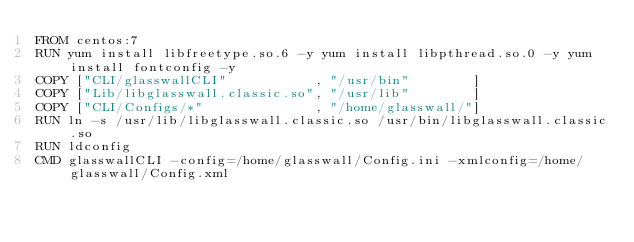<code> <loc_0><loc_0><loc_500><loc_500><_Dockerfile_>FROM centos:7
RUN yum install libfreetype.so.6 -y yum install libpthread.so.0 -y yum install fontconfig -y 
COPY ["CLI/glasswallCLI"           , "/usr/bin"        ] 
COPY ["Lib/libglasswall.classic.so", "/usr/lib"        ]
COPY ["CLI/Configs/*"              , "/home/glasswall/"]
RUN ln -s /usr/lib/libglasswall.classic.so /usr/bin/libglasswall.classic.so
RUN ldconfig
CMD glasswallCLI -config=/home/glasswall/Config.ini -xmlconfig=/home/glasswall/Config.xml</code> 